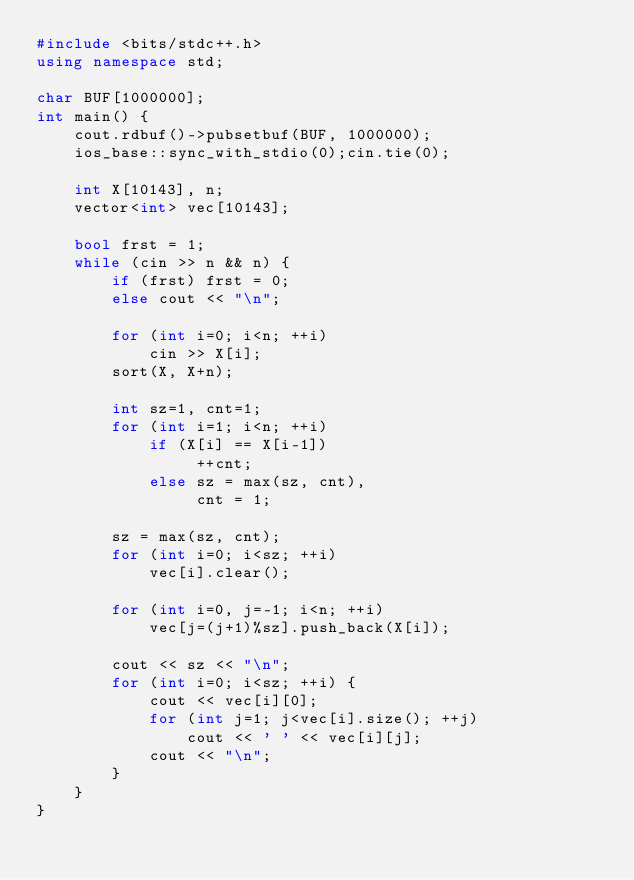<code> <loc_0><loc_0><loc_500><loc_500><_C++_>#include <bits/stdc++.h>
using namespace std;

char BUF[1000000];
int main() {
    cout.rdbuf()->pubsetbuf(BUF, 1000000);
    ios_base::sync_with_stdio(0);cin.tie(0);

    int X[10143], n;
    vector<int> vec[10143];

    bool frst = 1;
    while (cin >> n && n) {
        if (frst) frst = 0;
        else cout << "\n";

        for (int i=0; i<n; ++i)
            cin >> X[i];
        sort(X, X+n);

        int sz=1, cnt=1;
        for (int i=1; i<n; ++i)
            if (X[i] == X[i-1])
                 ++cnt;
            else sz = max(sz, cnt),
                 cnt = 1;

        sz = max(sz, cnt);
        for (int i=0; i<sz; ++i)
            vec[i].clear();

        for (int i=0, j=-1; i<n; ++i)
            vec[j=(j+1)%sz].push_back(X[i]);

        cout << sz << "\n";
        for (int i=0; i<sz; ++i) {
            cout << vec[i][0];
            for (int j=1; j<vec[i].size(); ++j)
                cout << ' ' << vec[i][j];
            cout << "\n";
        }
    }
}
</code> 